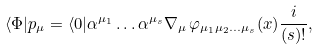Convert formula to latex. <formula><loc_0><loc_0><loc_500><loc_500>\langle \Phi | p _ { \mu } = \langle 0 | \alpha ^ { \mu _ { 1 } } \dots \alpha ^ { \mu _ { s } } \nabla _ { \mu } \, \varphi _ { \mu _ { 1 } \mu _ { 2 } \dots \mu _ { s } } ( x ) \frac { i } { ( s ) ! } ,</formula> 